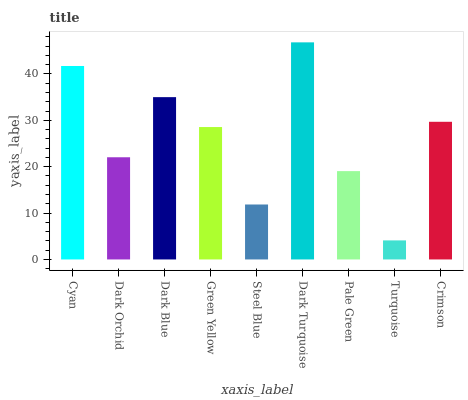Is Turquoise the minimum?
Answer yes or no. Yes. Is Dark Turquoise the maximum?
Answer yes or no. Yes. Is Dark Orchid the minimum?
Answer yes or no. No. Is Dark Orchid the maximum?
Answer yes or no. No. Is Cyan greater than Dark Orchid?
Answer yes or no. Yes. Is Dark Orchid less than Cyan?
Answer yes or no. Yes. Is Dark Orchid greater than Cyan?
Answer yes or no. No. Is Cyan less than Dark Orchid?
Answer yes or no. No. Is Green Yellow the high median?
Answer yes or no. Yes. Is Green Yellow the low median?
Answer yes or no. Yes. Is Dark Turquoise the high median?
Answer yes or no. No. Is Turquoise the low median?
Answer yes or no. No. 